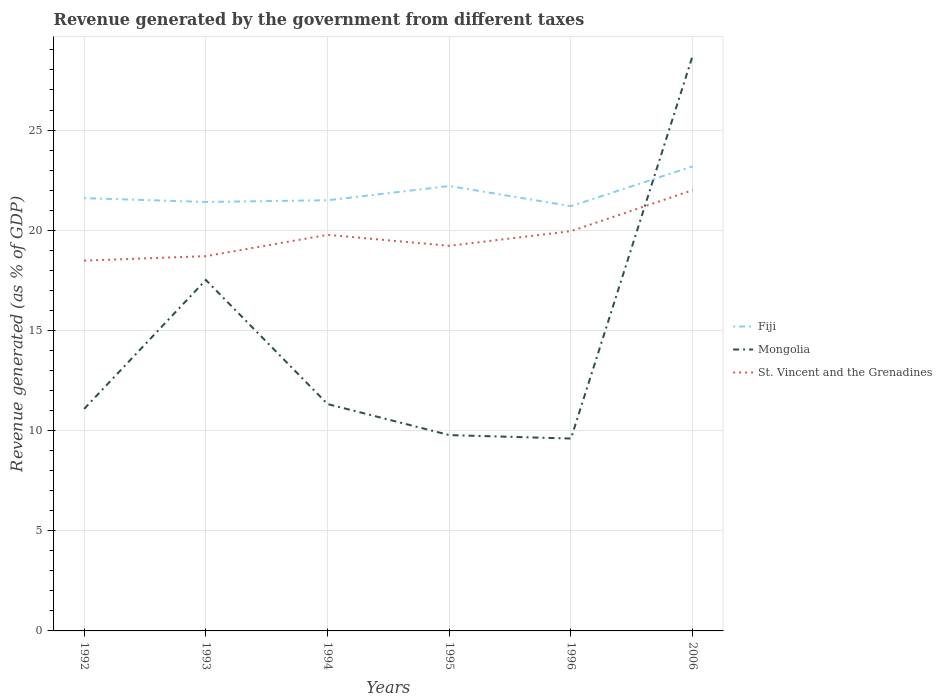Does the line corresponding to St. Vincent and the Grenadines intersect with the line corresponding to Mongolia?
Give a very brief answer. Yes. Across all years, what is the maximum revenue generated by the government in Mongolia?
Offer a terse response. 9.6. What is the total revenue generated by the government in Mongolia in the graph?
Provide a succinct answer. 7.74. What is the difference between the highest and the second highest revenue generated by the government in Fiji?
Provide a short and direct response. 1.98. What is the difference between the highest and the lowest revenue generated by the government in Mongolia?
Your answer should be very brief. 2. Is the revenue generated by the government in Mongolia strictly greater than the revenue generated by the government in Fiji over the years?
Give a very brief answer. No. Where does the legend appear in the graph?
Your answer should be very brief. Center right. How are the legend labels stacked?
Offer a very short reply. Vertical. What is the title of the graph?
Offer a very short reply. Revenue generated by the government from different taxes. Does "Serbia" appear as one of the legend labels in the graph?
Offer a very short reply. No. What is the label or title of the Y-axis?
Your answer should be very brief. Revenue generated (as % of GDP). What is the Revenue generated (as % of GDP) of Fiji in 1992?
Your answer should be very brief. 21.6. What is the Revenue generated (as % of GDP) of Mongolia in 1992?
Your answer should be compact. 11.08. What is the Revenue generated (as % of GDP) of St. Vincent and the Grenadines in 1992?
Your answer should be compact. 18.48. What is the Revenue generated (as % of GDP) of Fiji in 1993?
Your response must be concise. 21.41. What is the Revenue generated (as % of GDP) in Mongolia in 1993?
Keep it short and to the point. 17.52. What is the Revenue generated (as % of GDP) of St. Vincent and the Grenadines in 1993?
Your answer should be very brief. 18.71. What is the Revenue generated (as % of GDP) of Fiji in 1994?
Offer a very short reply. 21.5. What is the Revenue generated (as % of GDP) in Mongolia in 1994?
Keep it short and to the point. 11.32. What is the Revenue generated (as % of GDP) in St. Vincent and the Grenadines in 1994?
Your answer should be compact. 19.77. What is the Revenue generated (as % of GDP) in Fiji in 1995?
Give a very brief answer. 22.21. What is the Revenue generated (as % of GDP) in Mongolia in 1995?
Provide a short and direct response. 9.77. What is the Revenue generated (as % of GDP) in St. Vincent and the Grenadines in 1995?
Make the answer very short. 19.22. What is the Revenue generated (as % of GDP) in Fiji in 1996?
Your answer should be very brief. 21.2. What is the Revenue generated (as % of GDP) of Mongolia in 1996?
Ensure brevity in your answer.  9.6. What is the Revenue generated (as % of GDP) of St. Vincent and the Grenadines in 1996?
Offer a terse response. 19.95. What is the Revenue generated (as % of GDP) in Fiji in 2006?
Offer a very short reply. 23.19. What is the Revenue generated (as % of GDP) in Mongolia in 2006?
Ensure brevity in your answer.  28.71. What is the Revenue generated (as % of GDP) of St. Vincent and the Grenadines in 2006?
Offer a very short reply. 22. Across all years, what is the maximum Revenue generated (as % of GDP) in Fiji?
Your answer should be compact. 23.19. Across all years, what is the maximum Revenue generated (as % of GDP) in Mongolia?
Make the answer very short. 28.71. Across all years, what is the maximum Revenue generated (as % of GDP) of St. Vincent and the Grenadines?
Your answer should be compact. 22. Across all years, what is the minimum Revenue generated (as % of GDP) in Fiji?
Your answer should be compact. 21.2. Across all years, what is the minimum Revenue generated (as % of GDP) of Mongolia?
Your response must be concise. 9.6. Across all years, what is the minimum Revenue generated (as % of GDP) in St. Vincent and the Grenadines?
Your answer should be compact. 18.48. What is the total Revenue generated (as % of GDP) of Fiji in the graph?
Offer a terse response. 131.1. What is the total Revenue generated (as % of GDP) in Mongolia in the graph?
Provide a succinct answer. 88.01. What is the total Revenue generated (as % of GDP) in St. Vincent and the Grenadines in the graph?
Provide a succinct answer. 118.13. What is the difference between the Revenue generated (as % of GDP) in Fiji in 1992 and that in 1993?
Provide a short and direct response. 0.19. What is the difference between the Revenue generated (as % of GDP) in Mongolia in 1992 and that in 1993?
Ensure brevity in your answer.  -6.44. What is the difference between the Revenue generated (as % of GDP) of St. Vincent and the Grenadines in 1992 and that in 1993?
Provide a short and direct response. -0.22. What is the difference between the Revenue generated (as % of GDP) in Fiji in 1992 and that in 1994?
Provide a short and direct response. 0.11. What is the difference between the Revenue generated (as % of GDP) in Mongolia in 1992 and that in 1994?
Your answer should be compact. -0.24. What is the difference between the Revenue generated (as % of GDP) in St. Vincent and the Grenadines in 1992 and that in 1994?
Offer a terse response. -1.29. What is the difference between the Revenue generated (as % of GDP) of Fiji in 1992 and that in 1995?
Offer a very short reply. -0.61. What is the difference between the Revenue generated (as % of GDP) of Mongolia in 1992 and that in 1995?
Give a very brief answer. 1.31. What is the difference between the Revenue generated (as % of GDP) of St. Vincent and the Grenadines in 1992 and that in 1995?
Give a very brief answer. -0.74. What is the difference between the Revenue generated (as % of GDP) in Fiji in 1992 and that in 1996?
Keep it short and to the point. 0.4. What is the difference between the Revenue generated (as % of GDP) in Mongolia in 1992 and that in 1996?
Keep it short and to the point. 1.48. What is the difference between the Revenue generated (as % of GDP) of St. Vincent and the Grenadines in 1992 and that in 1996?
Give a very brief answer. -1.47. What is the difference between the Revenue generated (as % of GDP) in Fiji in 1992 and that in 2006?
Make the answer very short. -1.59. What is the difference between the Revenue generated (as % of GDP) in Mongolia in 1992 and that in 2006?
Provide a short and direct response. -17.63. What is the difference between the Revenue generated (as % of GDP) in St. Vincent and the Grenadines in 1992 and that in 2006?
Ensure brevity in your answer.  -3.52. What is the difference between the Revenue generated (as % of GDP) of Fiji in 1993 and that in 1994?
Offer a terse response. -0.09. What is the difference between the Revenue generated (as % of GDP) in Mongolia in 1993 and that in 1994?
Your answer should be compact. 6.19. What is the difference between the Revenue generated (as % of GDP) in St. Vincent and the Grenadines in 1993 and that in 1994?
Keep it short and to the point. -1.06. What is the difference between the Revenue generated (as % of GDP) in Fiji in 1993 and that in 1995?
Provide a short and direct response. -0.8. What is the difference between the Revenue generated (as % of GDP) of Mongolia in 1993 and that in 1995?
Make the answer very short. 7.74. What is the difference between the Revenue generated (as % of GDP) of St. Vincent and the Grenadines in 1993 and that in 1995?
Your answer should be compact. -0.52. What is the difference between the Revenue generated (as % of GDP) of Fiji in 1993 and that in 1996?
Offer a very short reply. 0.21. What is the difference between the Revenue generated (as % of GDP) in Mongolia in 1993 and that in 1996?
Provide a short and direct response. 7.92. What is the difference between the Revenue generated (as % of GDP) of St. Vincent and the Grenadines in 1993 and that in 1996?
Ensure brevity in your answer.  -1.25. What is the difference between the Revenue generated (as % of GDP) of Fiji in 1993 and that in 2006?
Provide a succinct answer. -1.78. What is the difference between the Revenue generated (as % of GDP) of Mongolia in 1993 and that in 2006?
Give a very brief answer. -11.19. What is the difference between the Revenue generated (as % of GDP) of St. Vincent and the Grenadines in 1993 and that in 2006?
Your answer should be very brief. -3.29. What is the difference between the Revenue generated (as % of GDP) in Fiji in 1994 and that in 1995?
Keep it short and to the point. -0.71. What is the difference between the Revenue generated (as % of GDP) in Mongolia in 1994 and that in 1995?
Your response must be concise. 1.55. What is the difference between the Revenue generated (as % of GDP) in St. Vincent and the Grenadines in 1994 and that in 1995?
Provide a short and direct response. 0.55. What is the difference between the Revenue generated (as % of GDP) of Fiji in 1994 and that in 1996?
Offer a very short reply. 0.29. What is the difference between the Revenue generated (as % of GDP) of Mongolia in 1994 and that in 1996?
Give a very brief answer. 1.72. What is the difference between the Revenue generated (as % of GDP) of St. Vincent and the Grenadines in 1994 and that in 1996?
Offer a terse response. -0.18. What is the difference between the Revenue generated (as % of GDP) in Fiji in 1994 and that in 2006?
Your answer should be very brief. -1.69. What is the difference between the Revenue generated (as % of GDP) of Mongolia in 1994 and that in 2006?
Your answer should be very brief. -17.39. What is the difference between the Revenue generated (as % of GDP) in St. Vincent and the Grenadines in 1994 and that in 2006?
Provide a succinct answer. -2.23. What is the difference between the Revenue generated (as % of GDP) of Mongolia in 1995 and that in 1996?
Offer a terse response. 0.17. What is the difference between the Revenue generated (as % of GDP) of St. Vincent and the Grenadines in 1995 and that in 1996?
Keep it short and to the point. -0.73. What is the difference between the Revenue generated (as % of GDP) of Fiji in 1995 and that in 2006?
Make the answer very short. -0.98. What is the difference between the Revenue generated (as % of GDP) of Mongolia in 1995 and that in 2006?
Make the answer very short. -18.94. What is the difference between the Revenue generated (as % of GDP) of St. Vincent and the Grenadines in 1995 and that in 2006?
Keep it short and to the point. -2.78. What is the difference between the Revenue generated (as % of GDP) of Fiji in 1996 and that in 2006?
Keep it short and to the point. -1.98. What is the difference between the Revenue generated (as % of GDP) of Mongolia in 1996 and that in 2006?
Your answer should be very brief. -19.11. What is the difference between the Revenue generated (as % of GDP) of St. Vincent and the Grenadines in 1996 and that in 2006?
Give a very brief answer. -2.04. What is the difference between the Revenue generated (as % of GDP) of Fiji in 1992 and the Revenue generated (as % of GDP) of Mongolia in 1993?
Ensure brevity in your answer.  4.08. What is the difference between the Revenue generated (as % of GDP) in Fiji in 1992 and the Revenue generated (as % of GDP) in St. Vincent and the Grenadines in 1993?
Your answer should be very brief. 2.9. What is the difference between the Revenue generated (as % of GDP) of Mongolia in 1992 and the Revenue generated (as % of GDP) of St. Vincent and the Grenadines in 1993?
Make the answer very short. -7.62. What is the difference between the Revenue generated (as % of GDP) of Fiji in 1992 and the Revenue generated (as % of GDP) of Mongolia in 1994?
Offer a very short reply. 10.28. What is the difference between the Revenue generated (as % of GDP) of Fiji in 1992 and the Revenue generated (as % of GDP) of St. Vincent and the Grenadines in 1994?
Keep it short and to the point. 1.83. What is the difference between the Revenue generated (as % of GDP) of Mongolia in 1992 and the Revenue generated (as % of GDP) of St. Vincent and the Grenadines in 1994?
Ensure brevity in your answer.  -8.69. What is the difference between the Revenue generated (as % of GDP) of Fiji in 1992 and the Revenue generated (as % of GDP) of Mongolia in 1995?
Provide a succinct answer. 11.83. What is the difference between the Revenue generated (as % of GDP) in Fiji in 1992 and the Revenue generated (as % of GDP) in St. Vincent and the Grenadines in 1995?
Your answer should be compact. 2.38. What is the difference between the Revenue generated (as % of GDP) of Mongolia in 1992 and the Revenue generated (as % of GDP) of St. Vincent and the Grenadines in 1995?
Ensure brevity in your answer.  -8.14. What is the difference between the Revenue generated (as % of GDP) of Fiji in 1992 and the Revenue generated (as % of GDP) of Mongolia in 1996?
Your answer should be very brief. 12. What is the difference between the Revenue generated (as % of GDP) in Fiji in 1992 and the Revenue generated (as % of GDP) in St. Vincent and the Grenadines in 1996?
Your answer should be very brief. 1.65. What is the difference between the Revenue generated (as % of GDP) in Mongolia in 1992 and the Revenue generated (as % of GDP) in St. Vincent and the Grenadines in 1996?
Offer a very short reply. -8.87. What is the difference between the Revenue generated (as % of GDP) of Fiji in 1992 and the Revenue generated (as % of GDP) of Mongolia in 2006?
Offer a terse response. -7.11. What is the difference between the Revenue generated (as % of GDP) in Fiji in 1992 and the Revenue generated (as % of GDP) in St. Vincent and the Grenadines in 2006?
Your answer should be very brief. -0.4. What is the difference between the Revenue generated (as % of GDP) of Mongolia in 1992 and the Revenue generated (as % of GDP) of St. Vincent and the Grenadines in 2006?
Provide a short and direct response. -10.92. What is the difference between the Revenue generated (as % of GDP) in Fiji in 1993 and the Revenue generated (as % of GDP) in Mongolia in 1994?
Ensure brevity in your answer.  10.09. What is the difference between the Revenue generated (as % of GDP) of Fiji in 1993 and the Revenue generated (as % of GDP) of St. Vincent and the Grenadines in 1994?
Ensure brevity in your answer.  1.64. What is the difference between the Revenue generated (as % of GDP) of Mongolia in 1993 and the Revenue generated (as % of GDP) of St. Vincent and the Grenadines in 1994?
Give a very brief answer. -2.25. What is the difference between the Revenue generated (as % of GDP) of Fiji in 1993 and the Revenue generated (as % of GDP) of Mongolia in 1995?
Keep it short and to the point. 11.64. What is the difference between the Revenue generated (as % of GDP) of Fiji in 1993 and the Revenue generated (as % of GDP) of St. Vincent and the Grenadines in 1995?
Your answer should be compact. 2.19. What is the difference between the Revenue generated (as % of GDP) of Mongolia in 1993 and the Revenue generated (as % of GDP) of St. Vincent and the Grenadines in 1995?
Offer a terse response. -1.7. What is the difference between the Revenue generated (as % of GDP) of Fiji in 1993 and the Revenue generated (as % of GDP) of Mongolia in 1996?
Keep it short and to the point. 11.81. What is the difference between the Revenue generated (as % of GDP) in Fiji in 1993 and the Revenue generated (as % of GDP) in St. Vincent and the Grenadines in 1996?
Give a very brief answer. 1.46. What is the difference between the Revenue generated (as % of GDP) in Mongolia in 1993 and the Revenue generated (as % of GDP) in St. Vincent and the Grenadines in 1996?
Provide a succinct answer. -2.44. What is the difference between the Revenue generated (as % of GDP) of Fiji in 1993 and the Revenue generated (as % of GDP) of Mongolia in 2006?
Keep it short and to the point. -7.3. What is the difference between the Revenue generated (as % of GDP) in Fiji in 1993 and the Revenue generated (as % of GDP) in St. Vincent and the Grenadines in 2006?
Provide a succinct answer. -0.59. What is the difference between the Revenue generated (as % of GDP) of Mongolia in 1993 and the Revenue generated (as % of GDP) of St. Vincent and the Grenadines in 2006?
Keep it short and to the point. -4.48. What is the difference between the Revenue generated (as % of GDP) of Fiji in 1994 and the Revenue generated (as % of GDP) of Mongolia in 1995?
Your answer should be very brief. 11.72. What is the difference between the Revenue generated (as % of GDP) of Fiji in 1994 and the Revenue generated (as % of GDP) of St. Vincent and the Grenadines in 1995?
Make the answer very short. 2.27. What is the difference between the Revenue generated (as % of GDP) in Mongolia in 1994 and the Revenue generated (as % of GDP) in St. Vincent and the Grenadines in 1995?
Offer a very short reply. -7.9. What is the difference between the Revenue generated (as % of GDP) of Fiji in 1994 and the Revenue generated (as % of GDP) of Mongolia in 1996?
Your response must be concise. 11.89. What is the difference between the Revenue generated (as % of GDP) in Fiji in 1994 and the Revenue generated (as % of GDP) in St. Vincent and the Grenadines in 1996?
Provide a short and direct response. 1.54. What is the difference between the Revenue generated (as % of GDP) in Mongolia in 1994 and the Revenue generated (as % of GDP) in St. Vincent and the Grenadines in 1996?
Offer a terse response. -8.63. What is the difference between the Revenue generated (as % of GDP) of Fiji in 1994 and the Revenue generated (as % of GDP) of Mongolia in 2006?
Make the answer very short. -7.21. What is the difference between the Revenue generated (as % of GDP) of Fiji in 1994 and the Revenue generated (as % of GDP) of St. Vincent and the Grenadines in 2006?
Your answer should be very brief. -0.5. What is the difference between the Revenue generated (as % of GDP) of Mongolia in 1994 and the Revenue generated (as % of GDP) of St. Vincent and the Grenadines in 2006?
Provide a short and direct response. -10.68. What is the difference between the Revenue generated (as % of GDP) in Fiji in 1995 and the Revenue generated (as % of GDP) in Mongolia in 1996?
Give a very brief answer. 12.6. What is the difference between the Revenue generated (as % of GDP) of Fiji in 1995 and the Revenue generated (as % of GDP) of St. Vincent and the Grenadines in 1996?
Keep it short and to the point. 2.25. What is the difference between the Revenue generated (as % of GDP) in Mongolia in 1995 and the Revenue generated (as % of GDP) in St. Vincent and the Grenadines in 1996?
Your response must be concise. -10.18. What is the difference between the Revenue generated (as % of GDP) in Fiji in 1995 and the Revenue generated (as % of GDP) in Mongolia in 2006?
Ensure brevity in your answer.  -6.5. What is the difference between the Revenue generated (as % of GDP) of Fiji in 1995 and the Revenue generated (as % of GDP) of St. Vincent and the Grenadines in 2006?
Provide a short and direct response. 0.21. What is the difference between the Revenue generated (as % of GDP) in Mongolia in 1995 and the Revenue generated (as % of GDP) in St. Vincent and the Grenadines in 2006?
Your answer should be very brief. -12.23. What is the difference between the Revenue generated (as % of GDP) of Fiji in 1996 and the Revenue generated (as % of GDP) of Mongolia in 2006?
Offer a terse response. -7.51. What is the difference between the Revenue generated (as % of GDP) in Fiji in 1996 and the Revenue generated (as % of GDP) in St. Vincent and the Grenadines in 2006?
Provide a short and direct response. -0.8. What is the difference between the Revenue generated (as % of GDP) of Mongolia in 1996 and the Revenue generated (as % of GDP) of St. Vincent and the Grenadines in 2006?
Give a very brief answer. -12.4. What is the average Revenue generated (as % of GDP) of Fiji per year?
Ensure brevity in your answer.  21.85. What is the average Revenue generated (as % of GDP) in Mongolia per year?
Your answer should be compact. 14.67. What is the average Revenue generated (as % of GDP) in St. Vincent and the Grenadines per year?
Offer a very short reply. 19.69. In the year 1992, what is the difference between the Revenue generated (as % of GDP) in Fiji and Revenue generated (as % of GDP) in Mongolia?
Ensure brevity in your answer.  10.52. In the year 1992, what is the difference between the Revenue generated (as % of GDP) of Fiji and Revenue generated (as % of GDP) of St. Vincent and the Grenadines?
Ensure brevity in your answer.  3.12. In the year 1992, what is the difference between the Revenue generated (as % of GDP) of Mongolia and Revenue generated (as % of GDP) of St. Vincent and the Grenadines?
Your response must be concise. -7.4. In the year 1993, what is the difference between the Revenue generated (as % of GDP) in Fiji and Revenue generated (as % of GDP) in Mongolia?
Your answer should be very brief. 3.89. In the year 1993, what is the difference between the Revenue generated (as % of GDP) of Fiji and Revenue generated (as % of GDP) of St. Vincent and the Grenadines?
Provide a short and direct response. 2.71. In the year 1993, what is the difference between the Revenue generated (as % of GDP) of Mongolia and Revenue generated (as % of GDP) of St. Vincent and the Grenadines?
Offer a terse response. -1.19. In the year 1994, what is the difference between the Revenue generated (as % of GDP) of Fiji and Revenue generated (as % of GDP) of Mongolia?
Give a very brief answer. 10.17. In the year 1994, what is the difference between the Revenue generated (as % of GDP) in Fiji and Revenue generated (as % of GDP) in St. Vincent and the Grenadines?
Make the answer very short. 1.73. In the year 1994, what is the difference between the Revenue generated (as % of GDP) in Mongolia and Revenue generated (as % of GDP) in St. Vincent and the Grenadines?
Your answer should be compact. -8.45. In the year 1995, what is the difference between the Revenue generated (as % of GDP) in Fiji and Revenue generated (as % of GDP) in Mongolia?
Offer a very short reply. 12.43. In the year 1995, what is the difference between the Revenue generated (as % of GDP) in Fiji and Revenue generated (as % of GDP) in St. Vincent and the Grenadines?
Your response must be concise. 2.98. In the year 1995, what is the difference between the Revenue generated (as % of GDP) of Mongolia and Revenue generated (as % of GDP) of St. Vincent and the Grenadines?
Keep it short and to the point. -9.45. In the year 1996, what is the difference between the Revenue generated (as % of GDP) in Fiji and Revenue generated (as % of GDP) in Mongolia?
Keep it short and to the point. 11.6. In the year 1996, what is the difference between the Revenue generated (as % of GDP) in Fiji and Revenue generated (as % of GDP) in St. Vincent and the Grenadines?
Ensure brevity in your answer.  1.25. In the year 1996, what is the difference between the Revenue generated (as % of GDP) in Mongolia and Revenue generated (as % of GDP) in St. Vincent and the Grenadines?
Your answer should be very brief. -10.35. In the year 2006, what is the difference between the Revenue generated (as % of GDP) of Fiji and Revenue generated (as % of GDP) of Mongolia?
Offer a very short reply. -5.52. In the year 2006, what is the difference between the Revenue generated (as % of GDP) in Fiji and Revenue generated (as % of GDP) in St. Vincent and the Grenadines?
Provide a succinct answer. 1.19. In the year 2006, what is the difference between the Revenue generated (as % of GDP) in Mongolia and Revenue generated (as % of GDP) in St. Vincent and the Grenadines?
Your answer should be very brief. 6.71. What is the ratio of the Revenue generated (as % of GDP) in Fiji in 1992 to that in 1993?
Your answer should be compact. 1.01. What is the ratio of the Revenue generated (as % of GDP) in Mongolia in 1992 to that in 1993?
Ensure brevity in your answer.  0.63. What is the ratio of the Revenue generated (as % of GDP) of St. Vincent and the Grenadines in 1992 to that in 1993?
Give a very brief answer. 0.99. What is the ratio of the Revenue generated (as % of GDP) of Fiji in 1992 to that in 1994?
Make the answer very short. 1. What is the ratio of the Revenue generated (as % of GDP) of Mongolia in 1992 to that in 1994?
Ensure brevity in your answer.  0.98. What is the ratio of the Revenue generated (as % of GDP) of St. Vincent and the Grenadines in 1992 to that in 1994?
Ensure brevity in your answer.  0.93. What is the ratio of the Revenue generated (as % of GDP) of Fiji in 1992 to that in 1995?
Provide a succinct answer. 0.97. What is the ratio of the Revenue generated (as % of GDP) in Mongolia in 1992 to that in 1995?
Your answer should be compact. 1.13. What is the ratio of the Revenue generated (as % of GDP) in St. Vincent and the Grenadines in 1992 to that in 1995?
Provide a succinct answer. 0.96. What is the ratio of the Revenue generated (as % of GDP) in Fiji in 1992 to that in 1996?
Your answer should be compact. 1.02. What is the ratio of the Revenue generated (as % of GDP) in Mongolia in 1992 to that in 1996?
Offer a terse response. 1.15. What is the ratio of the Revenue generated (as % of GDP) of St. Vincent and the Grenadines in 1992 to that in 1996?
Offer a very short reply. 0.93. What is the ratio of the Revenue generated (as % of GDP) in Fiji in 1992 to that in 2006?
Provide a succinct answer. 0.93. What is the ratio of the Revenue generated (as % of GDP) of Mongolia in 1992 to that in 2006?
Your response must be concise. 0.39. What is the ratio of the Revenue generated (as % of GDP) in St. Vincent and the Grenadines in 1992 to that in 2006?
Give a very brief answer. 0.84. What is the ratio of the Revenue generated (as % of GDP) of Fiji in 1993 to that in 1994?
Keep it short and to the point. 1. What is the ratio of the Revenue generated (as % of GDP) in Mongolia in 1993 to that in 1994?
Ensure brevity in your answer.  1.55. What is the ratio of the Revenue generated (as % of GDP) of St. Vincent and the Grenadines in 1993 to that in 1994?
Keep it short and to the point. 0.95. What is the ratio of the Revenue generated (as % of GDP) of Fiji in 1993 to that in 1995?
Offer a terse response. 0.96. What is the ratio of the Revenue generated (as % of GDP) of Mongolia in 1993 to that in 1995?
Make the answer very short. 1.79. What is the ratio of the Revenue generated (as % of GDP) of St. Vincent and the Grenadines in 1993 to that in 1995?
Ensure brevity in your answer.  0.97. What is the ratio of the Revenue generated (as % of GDP) of Fiji in 1993 to that in 1996?
Your response must be concise. 1.01. What is the ratio of the Revenue generated (as % of GDP) of Mongolia in 1993 to that in 1996?
Your answer should be compact. 1.82. What is the ratio of the Revenue generated (as % of GDP) in St. Vincent and the Grenadines in 1993 to that in 1996?
Keep it short and to the point. 0.94. What is the ratio of the Revenue generated (as % of GDP) of Fiji in 1993 to that in 2006?
Offer a very short reply. 0.92. What is the ratio of the Revenue generated (as % of GDP) of Mongolia in 1993 to that in 2006?
Make the answer very short. 0.61. What is the ratio of the Revenue generated (as % of GDP) of St. Vincent and the Grenadines in 1993 to that in 2006?
Offer a very short reply. 0.85. What is the ratio of the Revenue generated (as % of GDP) of Fiji in 1994 to that in 1995?
Keep it short and to the point. 0.97. What is the ratio of the Revenue generated (as % of GDP) in Mongolia in 1994 to that in 1995?
Your answer should be compact. 1.16. What is the ratio of the Revenue generated (as % of GDP) of St. Vincent and the Grenadines in 1994 to that in 1995?
Your answer should be compact. 1.03. What is the ratio of the Revenue generated (as % of GDP) of Fiji in 1994 to that in 1996?
Offer a very short reply. 1.01. What is the ratio of the Revenue generated (as % of GDP) in Mongolia in 1994 to that in 1996?
Make the answer very short. 1.18. What is the ratio of the Revenue generated (as % of GDP) in Fiji in 1994 to that in 2006?
Offer a terse response. 0.93. What is the ratio of the Revenue generated (as % of GDP) in Mongolia in 1994 to that in 2006?
Offer a terse response. 0.39. What is the ratio of the Revenue generated (as % of GDP) in St. Vincent and the Grenadines in 1994 to that in 2006?
Make the answer very short. 0.9. What is the ratio of the Revenue generated (as % of GDP) of Fiji in 1995 to that in 1996?
Your answer should be very brief. 1.05. What is the ratio of the Revenue generated (as % of GDP) of Mongolia in 1995 to that in 1996?
Offer a terse response. 1.02. What is the ratio of the Revenue generated (as % of GDP) of St. Vincent and the Grenadines in 1995 to that in 1996?
Offer a very short reply. 0.96. What is the ratio of the Revenue generated (as % of GDP) of Fiji in 1995 to that in 2006?
Offer a very short reply. 0.96. What is the ratio of the Revenue generated (as % of GDP) of Mongolia in 1995 to that in 2006?
Your response must be concise. 0.34. What is the ratio of the Revenue generated (as % of GDP) in St. Vincent and the Grenadines in 1995 to that in 2006?
Keep it short and to the point. 0.87. What is the ratio of the Revenue generated (as % of GDP) in Fiji in 1996 to that in 2006?
Ensure brevity in your answer.  0.91. What is the ratio of the Revenue generated (as % of GDP) in Mongolia in 1996 to that in 2006?
Your answer should be compact. 0.33. What is the ratio of the Revenue generated (as % of GDP) in St. Vincent and the Grenadines in 1996 to that in 2006?
Provide a succinct answer. 0.91. What is the difference between the highest and the second highest Revenue generated (as % of GDP) in Fiji?
Your answer should be very brief. 0.98. What is the difference between the highest and the second highest Revenue generated (as % of GDP) of Mongolia?
Your response must be concise. 11.19. What is the difference between the highest and the second highest Revenue generated (as % of GDP) of St. Vincent and the Grenadines?
Keep it short and to the point. 2.04. What is the difference between the highest and the lowest Revenue generated (as % of GDP) of Fiji?
Ensure brevity in your answer.  1.98. What is the difference between the highest and the lowest Revenue generated (as % of GDP) in Mongolia?
Ensure brevity in your answer.  19.11. What is the difference between the highest and the lowest Revenue generated (as % of GDP) of St. Vincent and the Grenadines?
Make the answer very short. 3.52. 